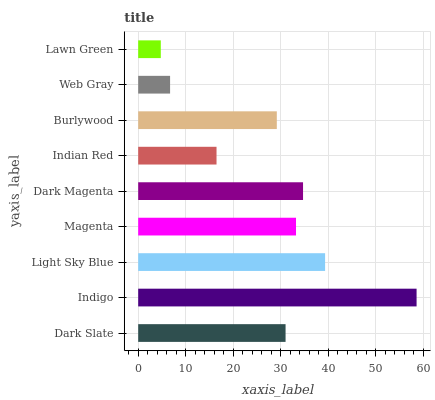Is Lawn Green the minimum?
Answer yes or no. Yes. Is Indigo the maximum?
Answer yes or no. Yes. Is Light Sky Blue the minimum?
Answer yes or no. No. Is Light Sky Blue the maximum?
Answer yes or no. No. Is Indigo greater than Light Sky Blue?
Answer yes or no. Yes. Is Light Sky Blue less than Indigo?
Answer yes or no. Yes. Is Light Sky Blue greater than Indigo?
Answer yes or no. No. Is Indigo less than Light Sky Blue?
Answer yes or no. No. Is Dark Slate the high median?
Answer yes or no. Yes. Is Dark Slate the low median?
Answer yes or no. Yes. Is Web Gray the high median?
Answer yes or no. No. Is Magenta the low median?
Answer yes or no. No. 